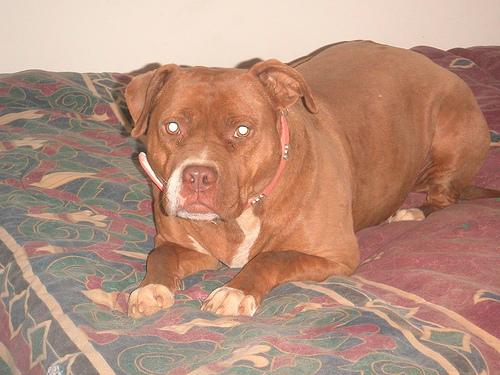Is this dog about to attack?
Keep it brief. No. Is this dog laying on the floor?
Short answer required. No. What type of animal is pictured?
Give a very brief answer. Dog. 